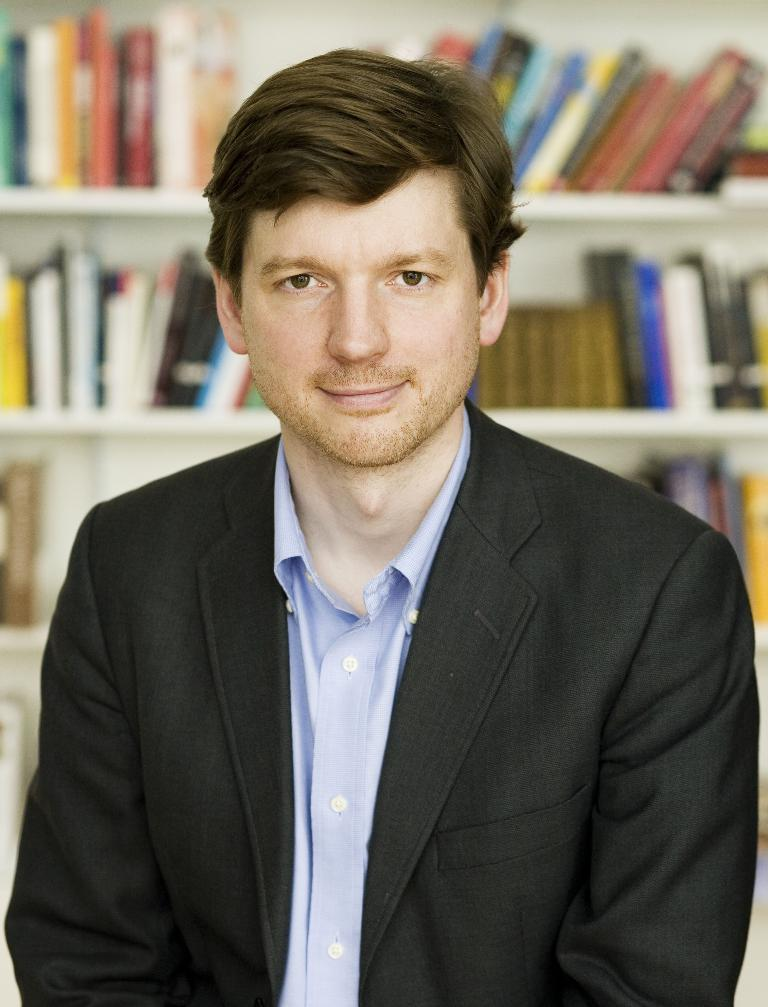Who is present in the image? There is a person in the image. What is the person doing in the image? The person is standing in front of a rack. What can be found on the rack in the image? The rack contains books. What color are the stranger's eyes in the image? There is no stranger present in the image, and therefore no information about their eyes can be provided. 